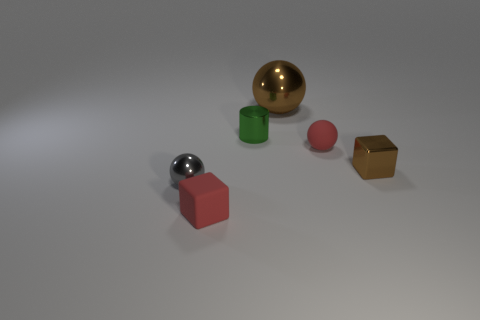How many other things are the same shape as the green thing?
Your answer should be compact. 0. How many things are shiny cylinders or large yellow cylinders?
Ensure brevity in your answer.  1. Is the color of the small rubber block the same as the tiny cylinder?
Give a very brief answer. No. Are there any other things that have the same size as the brown metallic sphere?
Provide a succinct answer. No. There is a brown metal thing behind the red thing behind the brown block; what shape is it?
Offer a very short reply. Sphere. Is the number of red objects less than the number of shiny objects?
Keep it short and to the point. Yes. What is the size of the object that is behind the small red block and on the left side of the cylinder?
Keep it short and to the point. Small. Do the rubber block and the brown shiny sphere have the same size?
Give a very brief answer. No. Do the tiny matte object that is in front of the brown metallic cube and the small matte sphere have the same color?
Provide a short and direct response. Yes. How many large brown metal things are to the left of the gray metallic object?
Provide a short and direct response. 0. 